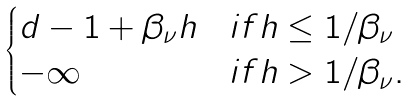<formula> <loc_0><loc_0><loc_500><loc_500>\begin{cases} d - 1 + \beta _ { \nu } h & i f h \leq 1 / \beta _ { \nu } \\ - \infty & i f h > 1 / \beta _ { \nu } . \end{cases}</formula> 